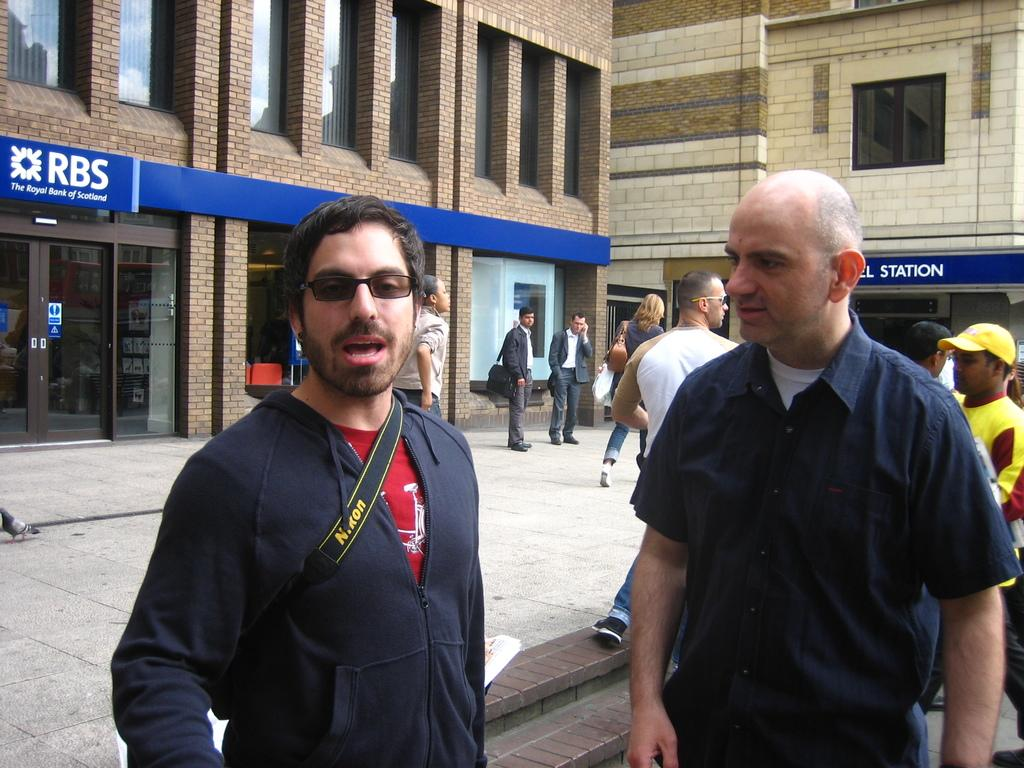What are the people in the image doing? The people in the image are standing on the road. What can be seen in the background of the image? There are name boards and buildings in the background. What type of riddle is being solved in the lunchroom in the image? There is no lunchroom or riddle present in the image. 